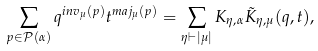Convert formula to latex. <formula><loc_0><loc_0><loc_500><loc_500>\sum _ { p \in \mathcal { P } ( \alpha ) } q ^ { i n v _ { \mu } ( p ) } t ^ { m a j _ { \mu } ( p ) } = \sum _ { \eta \vdash | \mu | } K _ { \eta , \alpha } \tilde { K } _ { \eta , \mu } ( q , t ) ,</formula> 